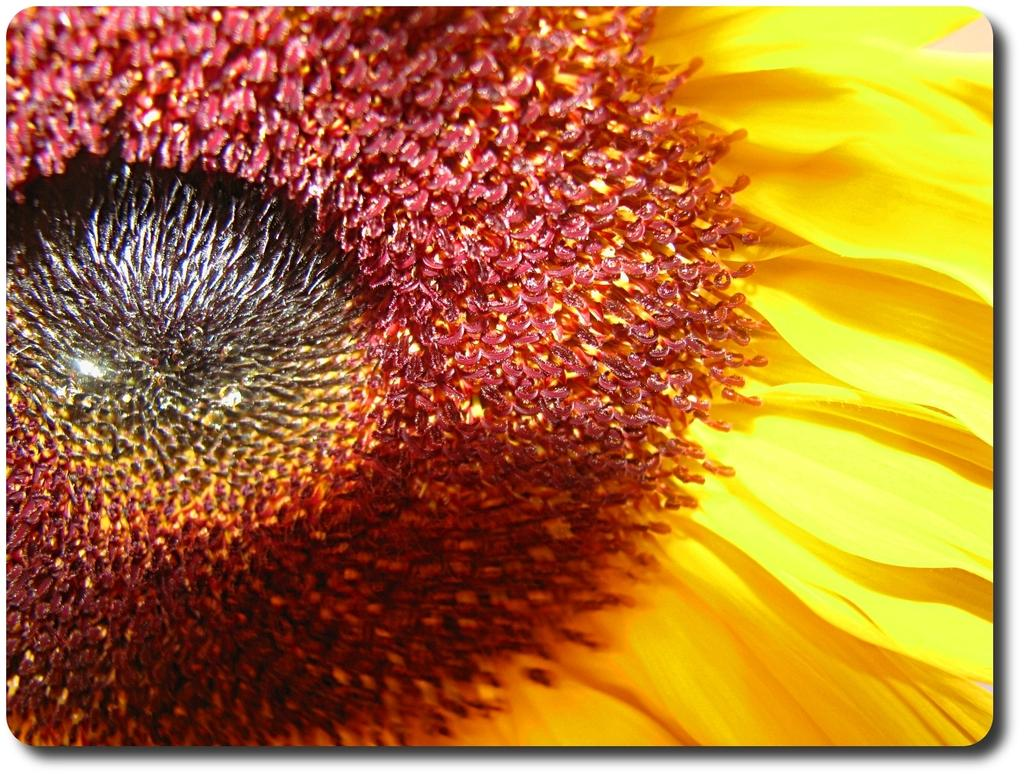What type of plant is featured in the image? There is a sunflower in the image. Can you describe the appearance of the sunflower? The sunflower has a large yellow flower head with dark brown seeds in the center. What is the primary color of the sunflower? The primary color of the sunflower is yellow. What type of noise can be heard coming from the sunflower in the image? Sunflowers do not produce noise, so there is no sound coming from the sunflower in the image. Can you describe the creator of the image? The provided facts do not include information about the creator of the image, so we cannot answer this question. 